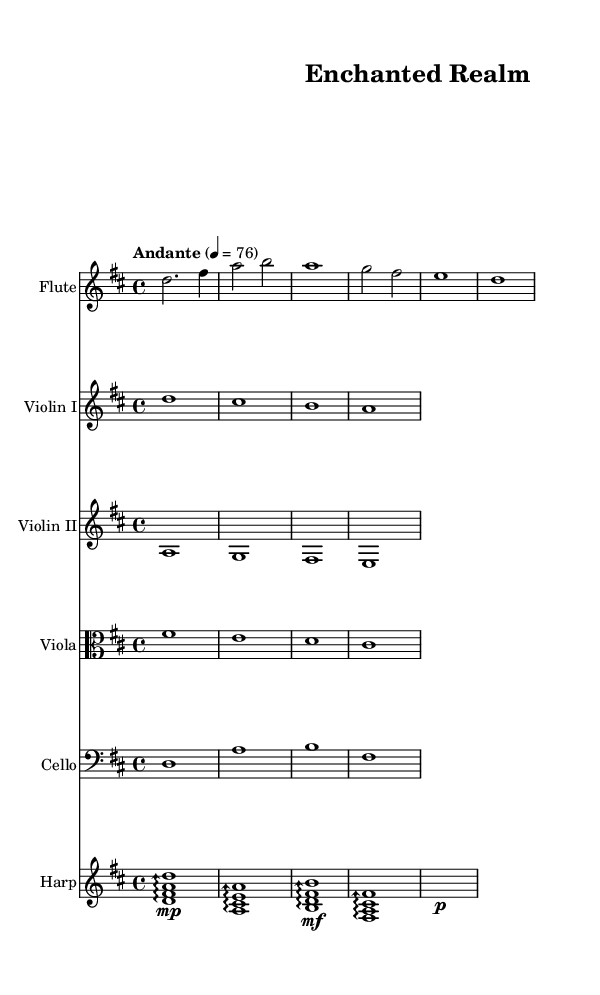What is the key signature of this music? The key signature is D major, indicated by two sharps. The music notation clearly shows the sharp symbols on the F and C lines of the staff, which is characteristic of D major.
Answer: D major What is the time signature of this music? The time signature is 4/4, which means there are four beats in each measure. This is indicated at the beginning of the score where the time signature is placed.
Answer: 4/4 What is the tempo marking of this piece? The tempo marking is "Andante," which indicates a moderately slow tempo. This can be found at the beginning of the score next to the tempo value of 76 beats per minute.
Answer: Andante Which instrument plays the arpeggios? The harp plays the arpeggios, as noted in the staff labeled "Harp." The notation shows arpeggio symbols underneath the notes indicating this style of playing.
Answer: Harp How many measures does the flute part contain? The flute part contains six measures. By counting the vertical lines that separate the measures within the flute staff, you can determine the total number of measures.
Answer: Six What is the lowest pitch instrument in this score? The cello is the lowest pitch instrument, indicated by its placement in the bass clef staff and the note values it plays. The cello sounds lower than the rest of the instruments in this ensemble.
Answer: Cello Which violin section plays in the lower register? The violin II section plays in the lower register, as evidenced by the notes which are lower in pitch compared to those in violin I. This differentiation is clear from the notation provided for each section.
Answer: Violin II 